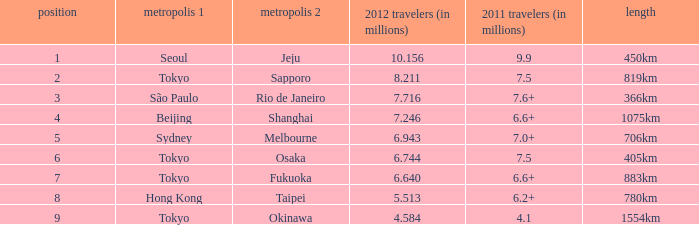640 million passengers in 2012? 6.6+. 